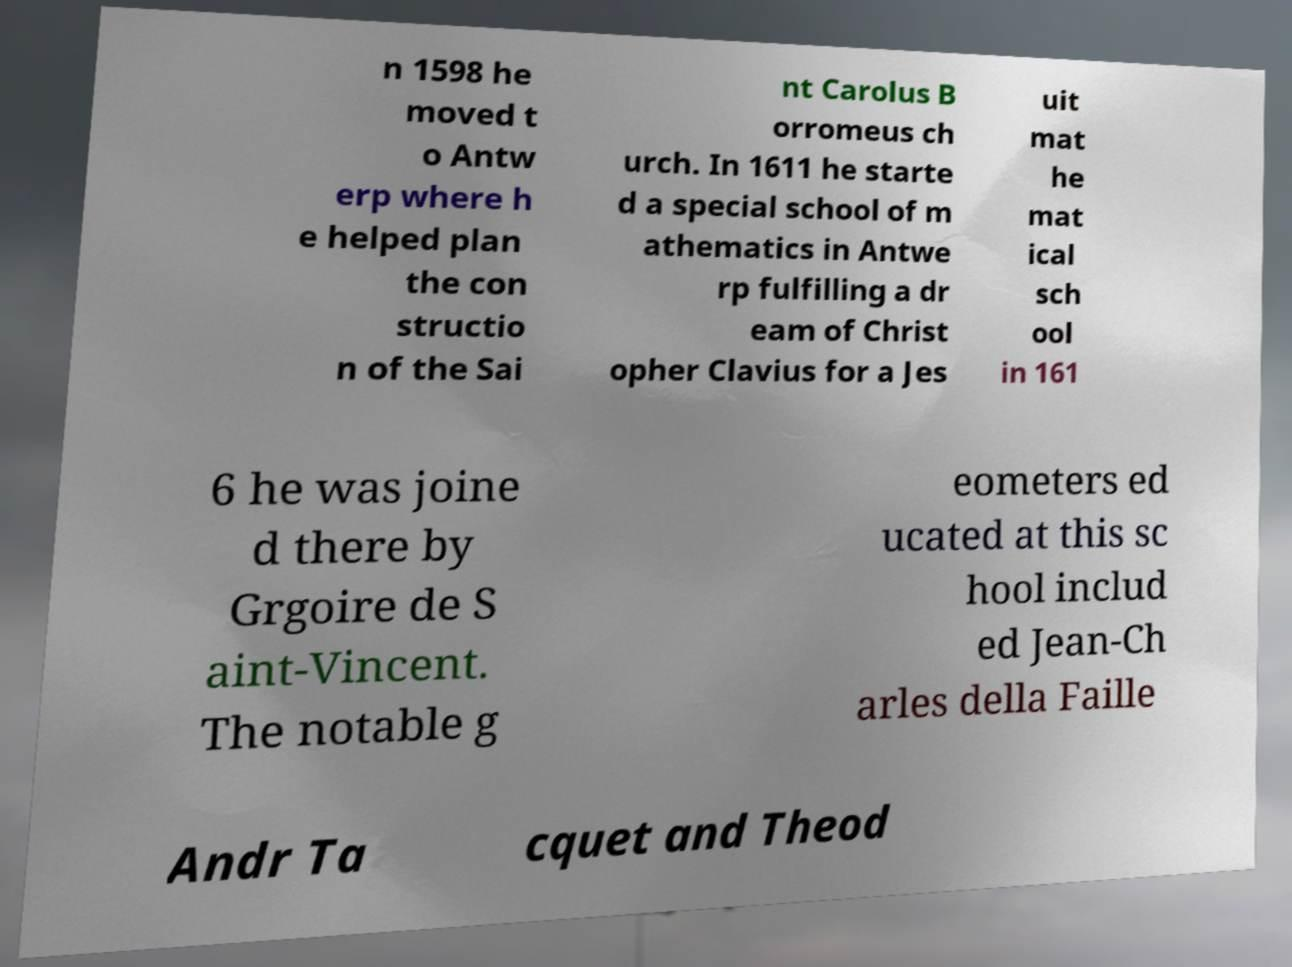Could you assist in decoding the text presented in this image and type it out clearly? n 1598 he moved t o Antw erp where h e helped plan the con structio n of the Sai nt Carolus B orromeus ch urch. In 1611 he starte d a special school of m athematics in Antwe rp fulfilling a dr eam of Christ opher Clavius for a Jes uit mat he mat ical sch ool in 161 6 he was joine d there by Grgoire de S aint-Vincent. The notable g eometers ed ucated at this sc hool includ ed Jean-Ch arles della Faille Andr Ta cquet and Theod 